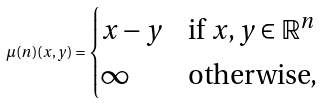Convert formula to latex. <formula><loc_0><loc_0><loc_500><loc_500>\mu ( n ) ( x , y ) = \begin{cases} x - y & \text {if } x , y \in \mathbb { R } ^ { n } \\ \infty & \text {otherwise,} \end{cases}</formula> 